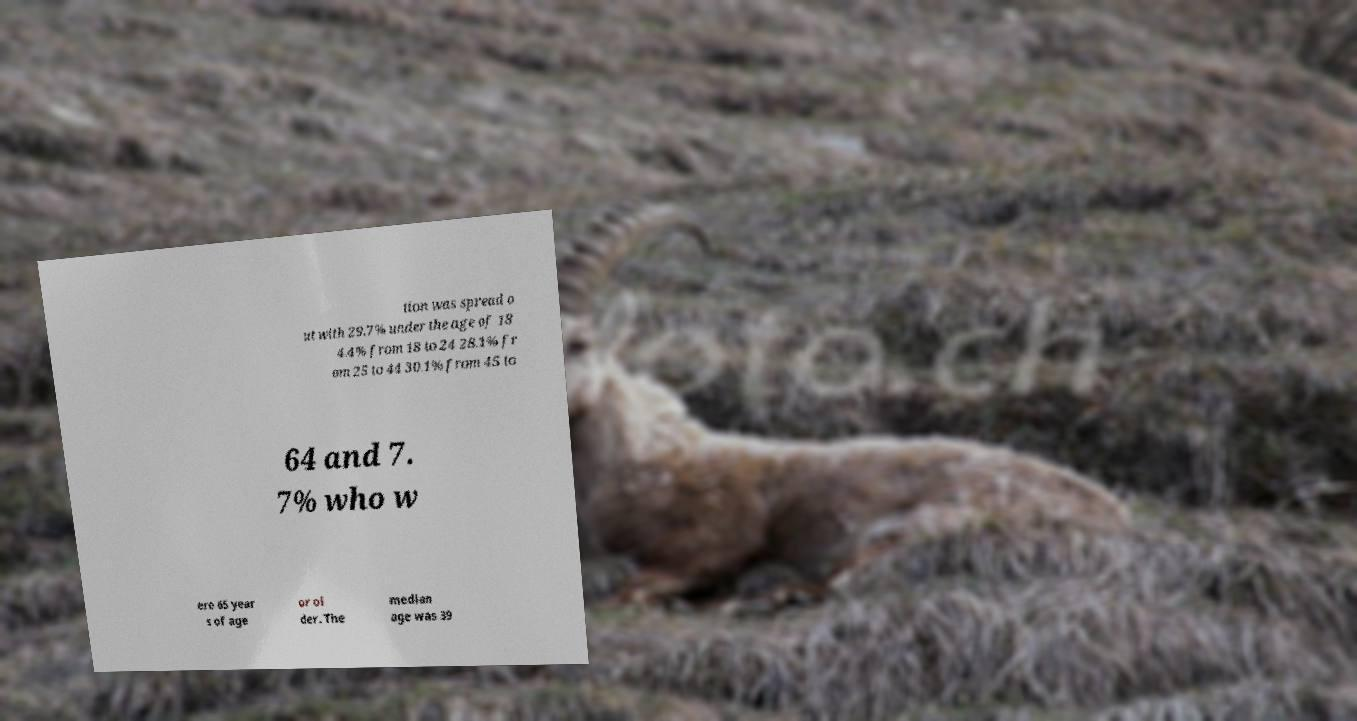I need the written content from this picture converted into text. Can you do that? tion was spread o ut with 29.7% under the age of 18 4.4% from 18 to 24 28.1% fr om 25 to 44 30.1% from 45 to 64 and 7. 7% who w ere 65 year s of age or ol der. The median age was 39 